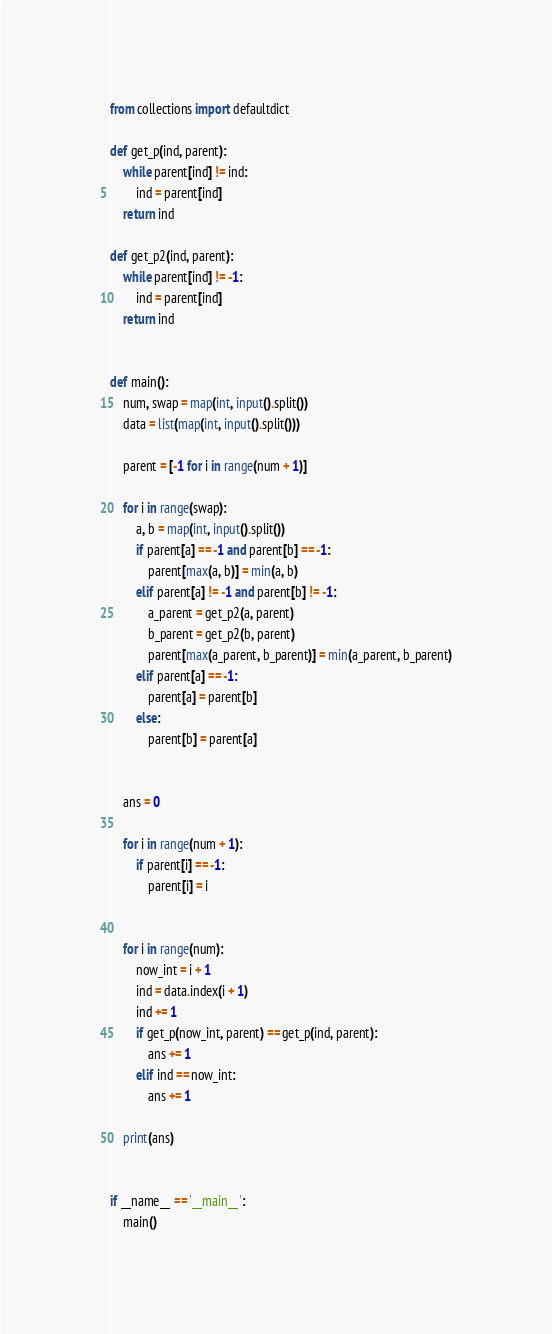Convert code to text. <code><loc_0><loc_0><loc_500><loc_500><_Python_>
from collections import defaultdict

def get_p(ind, parent):
    while parent[ind] != ind:
        ind = parent[ind]
    return ind

def get_p2(ind, parent):
    while parent[ind] != -1:
        ind = parent[ind]
    return ind


def main():
    num, swap = map(int, input().split())
    data = list(map(int, input().split()))

    parent = [-1 for i in range(num + 1)]

    for i in range(swap):
        a, b = map(int, input().split())
        if parent[a] == -1 and parent[b] == -1:
            parent[max(a, b)] = min(a, b)
        elif parent[a] != -1 and parent[b] != -1:
            a_parent = get_p2(a, parent)
            b_parent = get_p2(b, parent)
            parent[max(a_parent, b_parent)] = min(a_parent, b_parent)
        elif parent[a] == -1:
            parent[a] = parent[b]
        else:
            parent[b] = parent[a]


    ans = 0

    for i in range(num + 1):
        if parent[i] == -1:
            parent[i] = i


    for i in range(num):
        now_int = i + 1
        ind = data.index(i + 1)
        ind += 1
        if get_p(now_int, parent) == get_p(ind, parent):
            ans += 1
        elif ind == now_int:
            ans += 1

    print(ans)


if __name__ == '__main__':
    main()</code> 